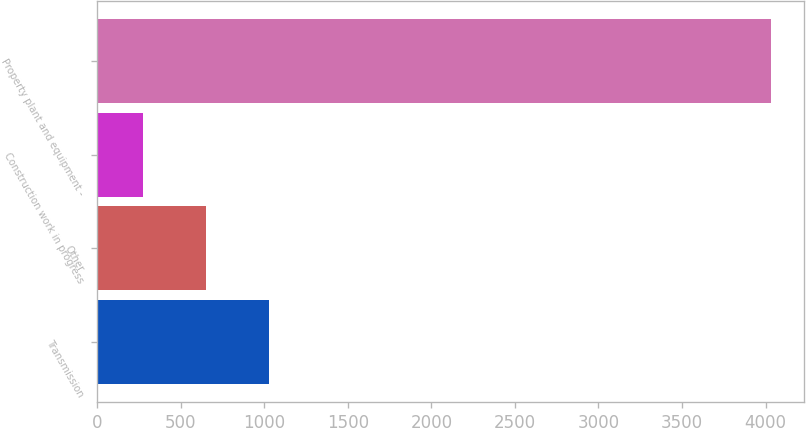Convert chart. <chart><loc_0><loc_0><loc_500><loc_500><bar_chart><fcel>Transmission<fcel>Other<fcel>Construction work in progress<fcel>Property plant and equipment -<nl><fcel>1027.6<fcel>652.3<fcel>277<fcel>4030<nl></chart> 